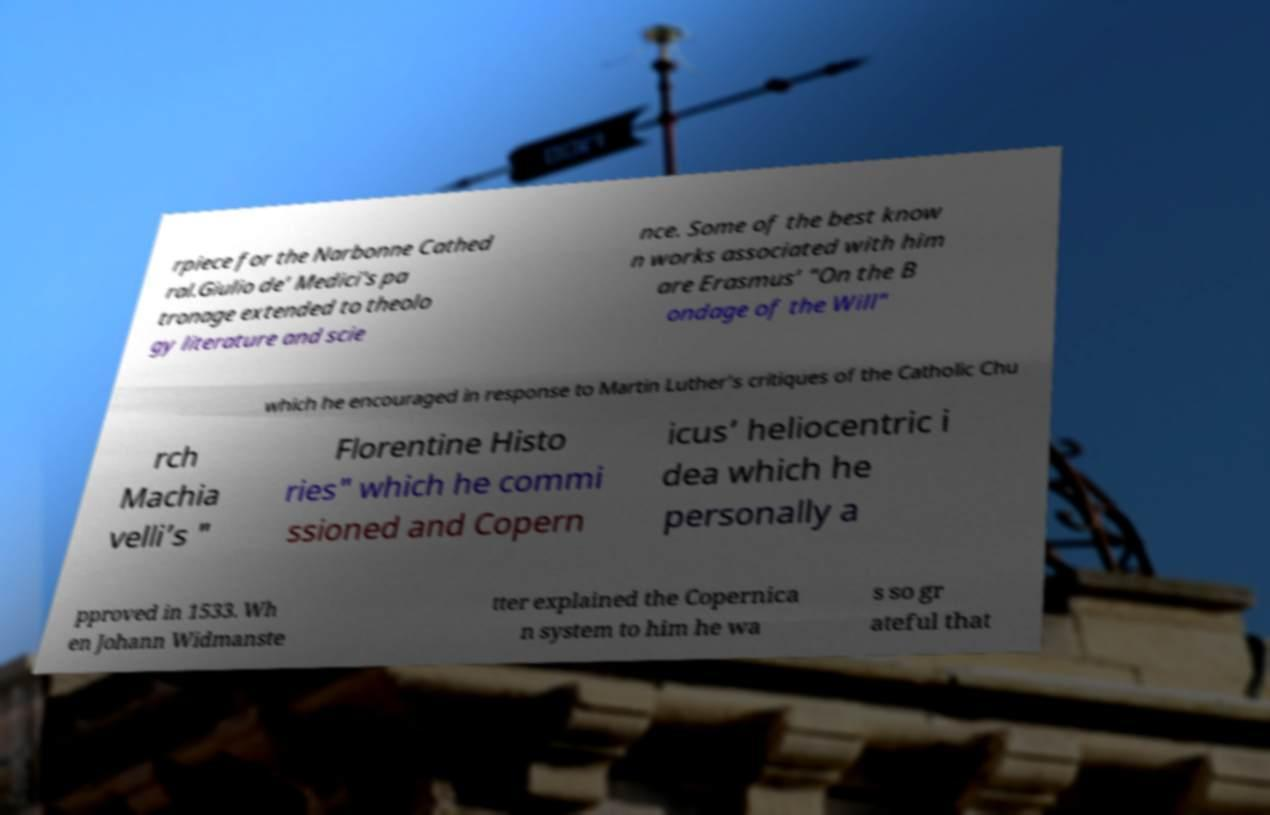I need the written content from this picture converted into text. Can you do that? rpiece for the Narbonne Cathed ral.Giulio de’ Medici's pa tronage extended to theolo gy literature and scie nce. Some of the best know n works associated with him are Erasmus’ "On the B ondage of the Will" which he encouraged in response to Martin Luther’s critiques of the Catholic Chu rch Machia velli’s " Florentine Histo ries" which he commi ssioned and Copern icus’ heliocentric i dea which he personally a pproved in 1533. Wh en Johann Widmanste tter explained the Copernica n system to him he wa s so gr ateful that 